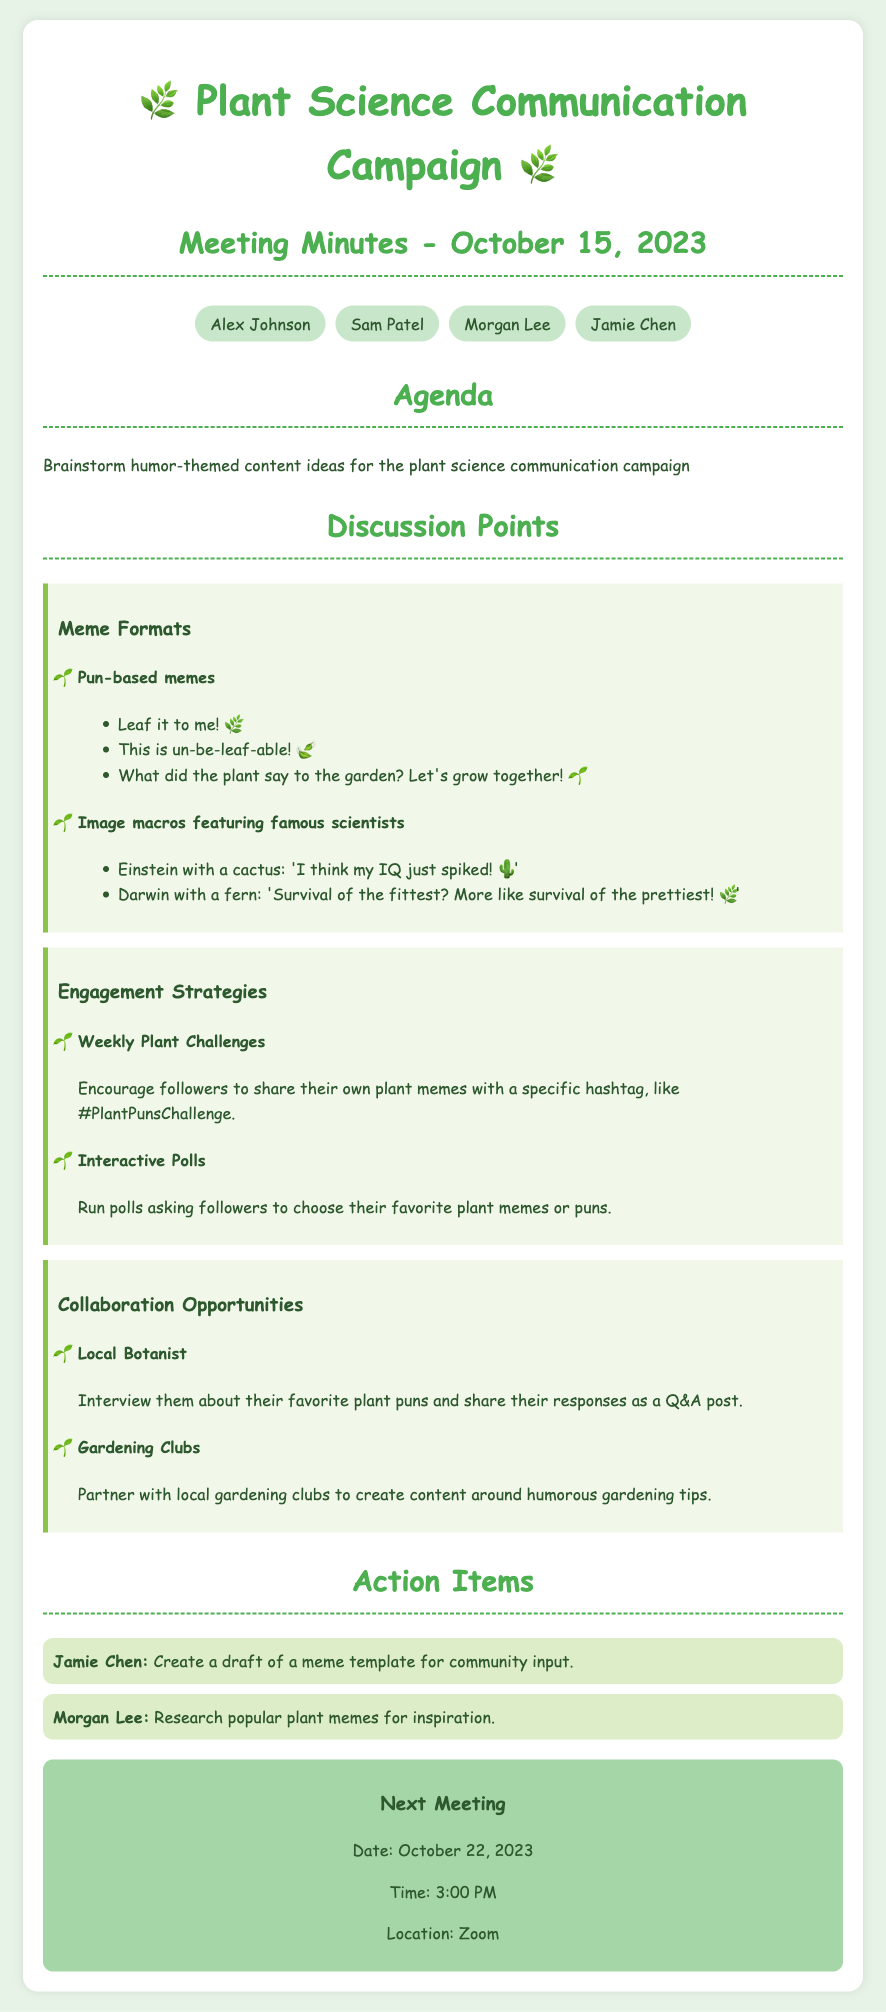What is the date of the meeting? The date of the meeting is indicated in the title, which states "Meeting Minutes - October 15, 2023."
Answer: October 15, 2023 Who is responsible for creating a draft of a meme template? The action items section specifies that "Jamie Chen" is charged with this task.
Answer: Jamie Chen What is one of the pun-based meme ideas mentioned? The document provides several pun-based meme ideas, one of which is "Leaf it to me!"
Answer: Leaf it to me! What time is the next meeting scheduled? The next meeting’s time is explicitly stated as "3:00 PM."
Answer: 3:00 PM What is the proposed hashtag for the weekly plant challenge? The document mentions a specific hashtag as part of the engagement strategy, which is "#PlantPunsChallenge."
Answer: #PlantPunsChallenge Which famous scientist is featured with a cactus in a meme idea? The document lists "Einstein" alongside the cactus meme.
Answer: Einstein What are the collaboration opportunities mentioned in the meeting? The document outlines specific collaboration opportunities, including "Local Botanist" and "Gardening Clubs."
Answer: Local Botanist, Gardening Clubs What is the purpose of the interactive polls suggested? The document states that interactive polls will ask followers to choose their favorite plant memes or puns.
Answer: Choose favorite plant memes or puns 